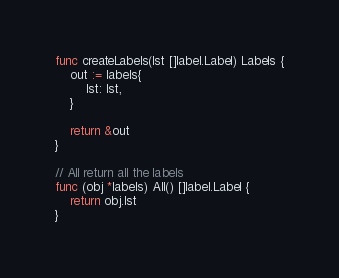<code> <loc_0><loc_0><loc_500><loc_500><_Go_>func createLabels(lst []label.Label) Labels {
	out := labels{
		lst: lst,
	}

	return &out
}

// All return all the labels
func (obj *labels) All() []label.Label {
	return obj.lst
}
</code> 